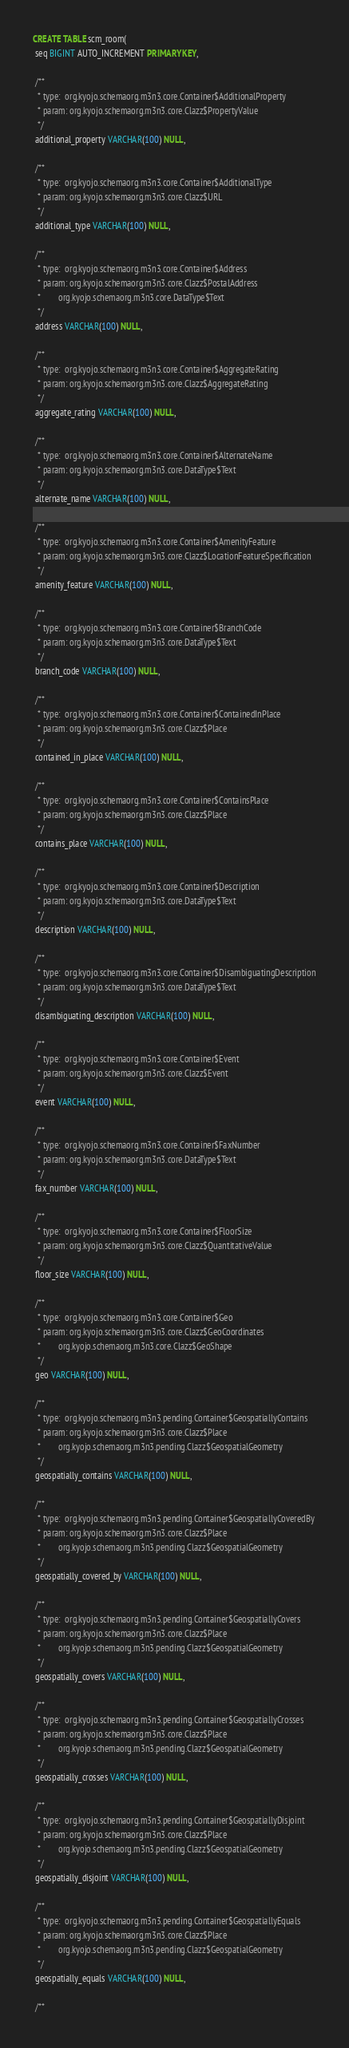Convert code to text. <code><loc_0><loc_0><loc_500><loc_500><_SQL_>CREATE TABLE scm_room(
 seq BIGINT AUTO_INCREMENT PRIMARY KEY,

 /**
  * type:  org.kyojo.schemaorg.m3n3.core.Container$AdditionalProperty
  * param: org.kyojo.schemaorg.m3n3.core.Clazz$PropertyValue
  */
 additional_property VARCHAR(100) NULL,

 /**
  * type:  org.kyojo.schemaorg.m3n3.core.Container$AdditionalType
  * param: org.kyojo.schemaorg.m3n3.core.Clazz$URL
  */
 additional_type VARCHAR(100) NULL,

 /**
  * type:  org.kyojo.schemaorg.m3n3.core.Container$Address
  * param: org.kyojo.schemaorg.m3n3.core.Clazz$PostalAddress
  *        org.kyojo.schemaorg.m3n3.core.DataType$Text
  */
 address VARCHAR(100) NULL,

 /**
  * type:  org.kyojo.schemaorg.m3n3.core.Container$AggregateRating
  * param: org.kyojo.schemaorg.m3n3.core.Clazz$AggregateRating
  */
 aggregate_rating VARCHAR(100) NULL,

 /**
  * type:  org.kyojo.schemaorg.m3n3.core.Container$AlternateName
  * param: org.kyojo.schemaorg.m3n3.core.DataType$Text
  */
 alternate_name VARCHAR(100) NULL,

 /**
  * type:  org.kyojo.schemaorg.m3n3.core.Container$AmenityFeature
  * param: org.kyojo.schemaorg.m3n3.core.Clazz$LocationFeatureSpecification
  */
 amenity_feature VARCHAR(100) NULL,

 /**
  * type:  org.kyojo.schemaorg.m3n3.core.Container$BranchCode
  * param: org.kyojo.schemaorg.m3n3.core.DataType$Text
  */
 branch_code VARCHAR(100) NULL,

 /**
  * type:  org.kyojo.schemaorg.m3n3.core.Container$ContainedInPlace
  * param: org.kyojo.schemaorg.m3n3.core.Clazz$Place
  */
 contained_in_place VARCHAR(100) NULL,

 /**
  * type:  org.kyojo.schemaorg.m3n3.core.Container$ContainsPlace
  * param: org.kyojo.schemaorg.m3n3.core.Clazz$Place
  */
 contains_place VARCHAR(100) NULL,

 /**
  * type:  org.kyojo.schemaorg.m3n3.core.Container$Description
  * param: org.kyojo.schemaorg.m3n3.core.DataType$Text
  */
 description VARCHAR(100) NULL,

 /**
  * type:  org.kyojo.schemaorg.m3n3.core.Container$DisambiguatingDescription
  * param: org.kyojo.schemaorg.m3n3.core.DataType$Text
  */
 disambiguating_description VARCHAR(100) NULL,

 /**
  * type:  org.kyojo.schemaorg.m3n3.core.Container$Event
  * param: org.kyojo.schemaorg.m3n3.core.Clazz$Event
  */
 event VARCHAR(100) NULL,

 /**
  * type:  org.kyojo.schemaorg.m3n3.core.Container$FaxNumber
  * param: org.kyojo.schemaorg.m3n3.core.DataType$Text
  */
 fax_number VARCHAR(100) NULL,

 /**
  * type:  org.kyojo.schemaorg.m3n3.core.Container$FloorSize
  * param: org.kyojo.schemaorg.m3n3.core.Clazz$QuantitativeValue
  */
 floor_size VARCHAR(100) NULL,

 /**
  * type:  org.kyojo.schemaorg.m3n3.core.Container$Geo
  * param: org.kyojo.schemaorg.m3n3.core.Clazz$GeoCoordinates
  *        org.kyojo.schemaorg.m3n3.core.Clazz$GeoShape
  */
 geo VARCHAR(100) NULL,

 /**
  * type:  org.kyojo.schemaorg.m3n3.pending.Container$GeospatiallyContains
  * param: org.kyojo.schemaorg.m3n3.core.Clazz$Place
  *        org.kyojo.schemaorg.m3n3.pending.Clazz$GeospatialGeometry
  */
 geospatially_contains VARCHAR(100) NULL,

 /**
  * type:  org.kyojo.schemaorg.m3n3.pending.Container$GeospatiallyCoveredBy
  * param: org.kyojo.schemaorg.m3n3.core.Clazz$Place
  *        org.kyojo.schemaorg.m3n3.pending.Clazz$GeospatialGeometry
  */
 geospatially_covered_by VARCHAR(100) NULL,

 /**
  * type:  org.kyojo.schemaorg.m3n3.pending.Container$GeospatiallyCovers
  * param: org.kyojo.schemaorg.m3n3.core.Clazz$Place
  *        org.kyojo.schemaorg.m3n3.pending.Clazz$GeospatialGeometry
  */
 geospatially_covers VARCHAR(100) NULL,

 /**
  * type:  org.kyojo.schemaorg.m3n3.pending.Container$GeospatiallyCrosses
  * param: org.kyojo.schemaorg.m3n3.core.Clazz$Place
  *        org.kyojo.schemaorg.m3n3.pending.Clazz$GeospatialGeometry
  */
 geospatially_crosses VARCHAR(100) NULL,

 /**
  * type:  org.kyojo.schemaorg.m3n3.pending.Container$GeospatiallyDisjoint
  * param: org.kyojo.schemaorg.m3n3.core.Clazz$Place
  *        org.kyojo.schemaorg.m3n3.pending.Clazz$GeospatialGeometry
  */
 geospatially_disjoint VARCHAR(100) NULL,

 /**
  * type:  org.kyojo.schemaorg.m3n3.pending.Container$GeospatiallyEquals
  * param: org.kyojo.schemaorg.m3n3.core.Clazz$Place
  *        org.kyojo.schemaorg.m3n3.pending.Clazz$GeospatialGeometry
  */
 geospatially_equals VARCHAR(100) NULL,

 /**</code> 